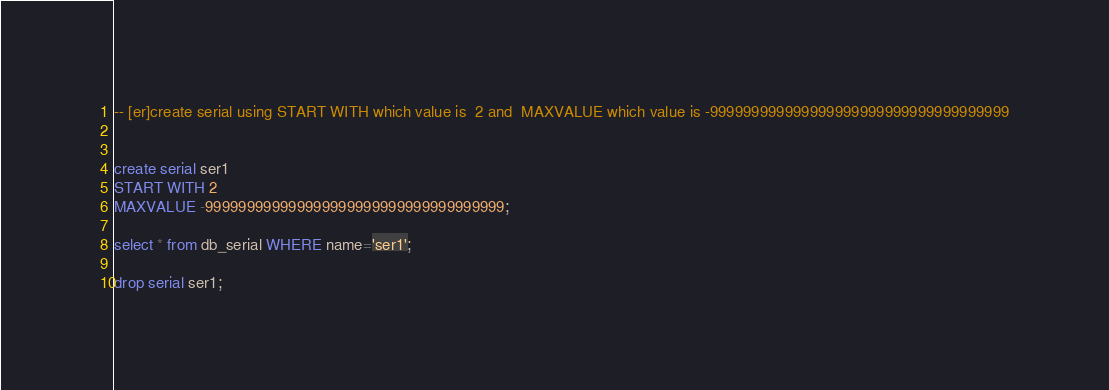<code> <loc_0><loc_0><loc_500><loc_500><_SQL_>-- [er]create serial using START WITH which value is  2 and  MAXVALUE which value is -999999999999999999999999999999999999


create serial ser1
START WITH 2
MAXVALUE -999999999999999999999999999999999999;

select * from db_serial WHERE name='ser1';

drop serial ser1;
</code> 